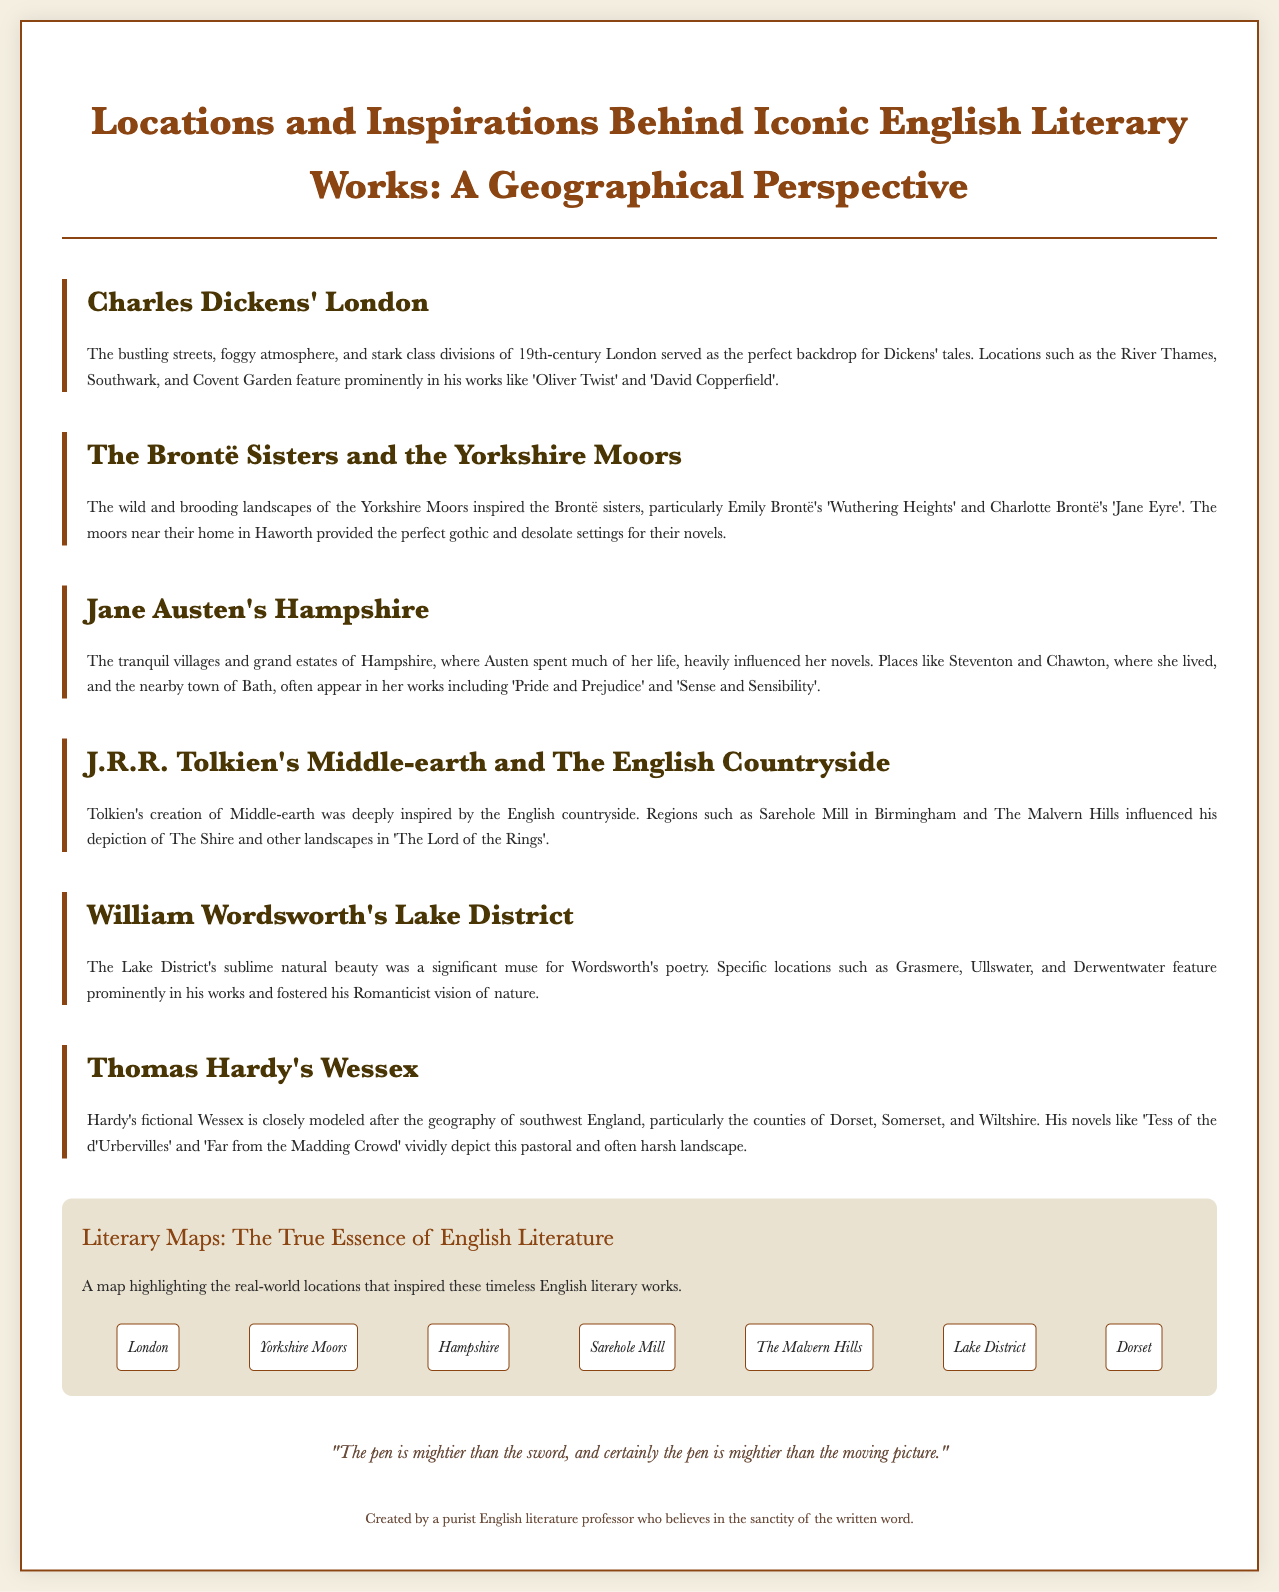What inspired Charles Dickens' tales? The document states that the bustling streets, foggy atmosphere, and stark class divisions of 19th-century London served as the perfect backdrop for Dickens' tales.
Answer: London Which Brontë sister wrote 'Wuthering Heights'? The section about the Brontë Sisters mentions that Emily Brontë wrote 'Wuthering Heights'.
Answer: Emily Brontë What geographical area does Thomas Hardy's Wessex represent? The document indicates that Hardy's fictional Wessex closely models the geography of southwest England, specifically counties of Dorset, Somerset, and Wiltshire.
Answer: Dorset, Somerset, and Wiltshire What natural feature significantly influenced William Wordsworth's poetry? The section on Wordsworth notes that the Lake District's sublime natural beauty was a significant muse for his poetry.
Answer: Lake District Which town in Hampshire is associated with Jane Austen? The document mentions places like Steventon and Chawton in Hampshire related to Jane Austen.
Answer: Steventon How many locations are highlighted in the map section? The map section lists seven distinct literary locations.
Answer: Seven What genre of literature did the Yorkshire Moors inspire? The Brontë sisters' works inspired by the Yorkshire Moors are often considered gothic literature, as referenced in the document.
Answer: Gothic literature What is the highlighted sentiment about the written word in the quote? The quote emphasizes that "the pen is mightier than the sword," suggesting a belief in the superiority of writing over film.
Answer: Mightier than the sword What literary work is set in Middle-earth? It is stated that 'The Lord of the Rings' is set in Middle-earth.
Answer: The Lord of the Rings 